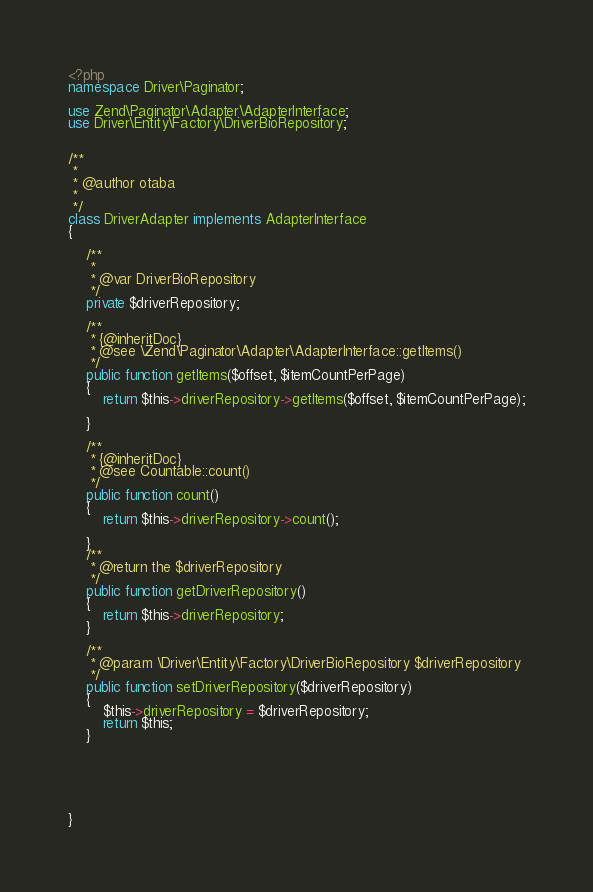Convert code to text. <code><loc_0><loc_0><loc_500><loc_500><_PHP_><?php
namespace Driver\Paginator;

use Zend\Paginator\Adapter\AdapterInterface;
use Driver\Entity\Factory\DriverBioRepository;


/**
 *
 * @author otaba
 *        
 */
class DriverAdapter implements AdapterInterface
{
    
    /**
     * 
     * @var DriverBioRepository
     */
    private $driverRepository;
    
    /**
     * {@inheritDoc}
     * @see \Zend\Paginator\Adapter\AdapterInterface::getItems()
     */
    public function getItems($offset, $itemCountPerPage)
    {
        return $this->driverRepository->getItems($offset, $itemCountPerPage);
        
    }

    /**
     * {@inheritDoc}
     * @see Countable::count()
     */
    public function count()
    {
        return $this->driverRepository->count();
        
    }
    /**
     * @return the $driverRepository
     */
    public function getDriverRepository()
    {
        return $this->driverRepository;
    }

    /**
     * @param \Driver\Entity\Factory\DriverBioRepository $driverRepository
     */
    public function setDriverRepository($driverRepository)
    {
        $this->driverRepository = $driverRepository;
        return $this;
    }

   



   
}

</code> 